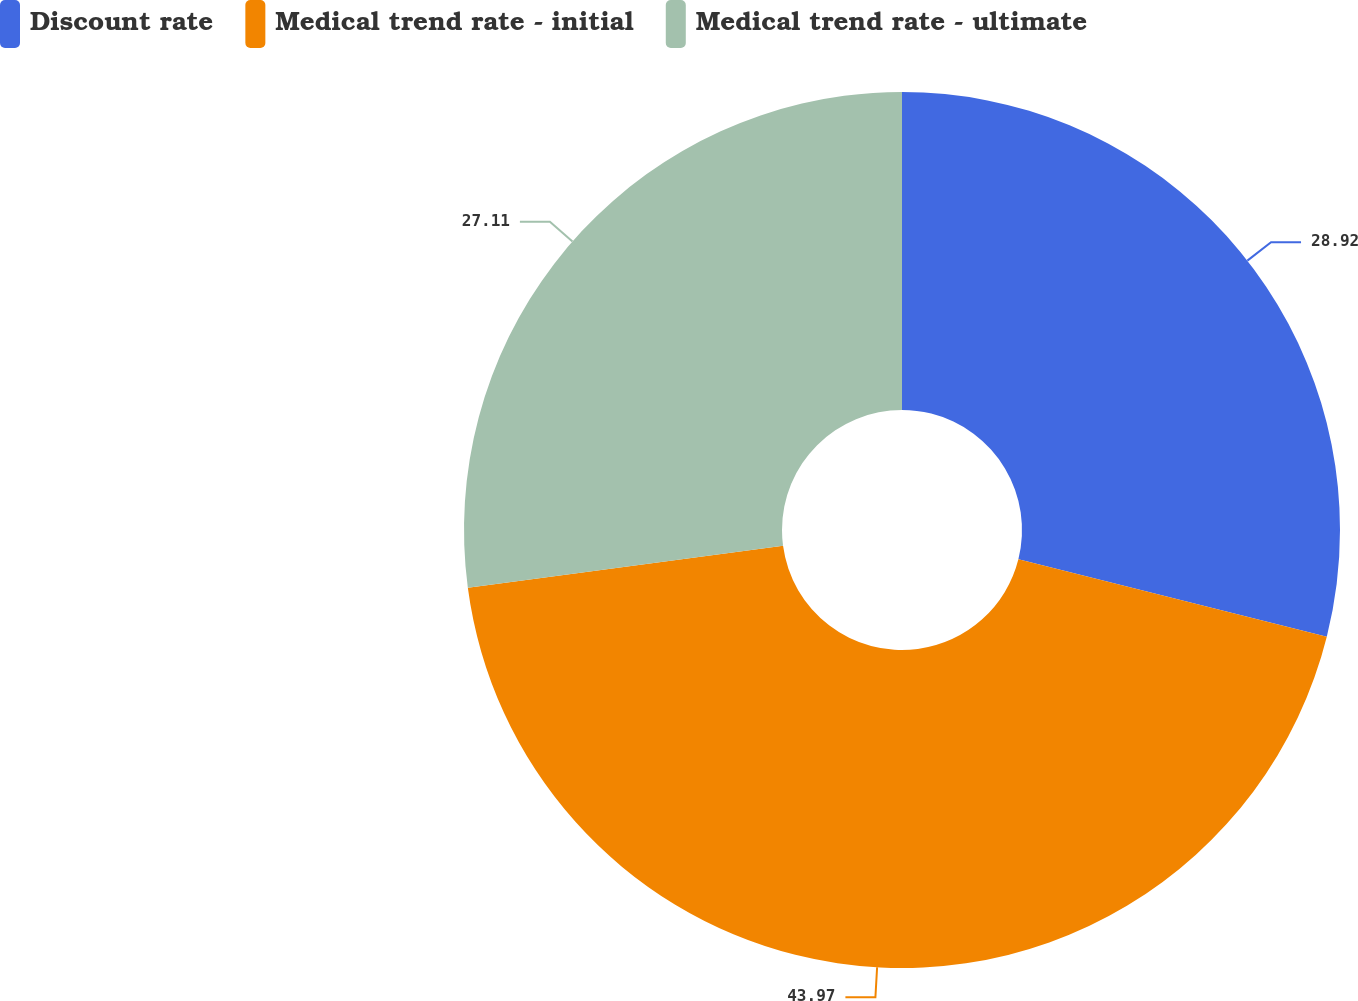Convert chart to OTSL. <chart><loc_0><loc_0><loc_500><loc_500><pie_chart><fcel>Discount rate<fcel>Medical trend rate - initial<fcel>Medical trend rate - ultimate<nl><fcel>28.92%<fcel>43.98%<fcel>27.11%<nl></chart> 